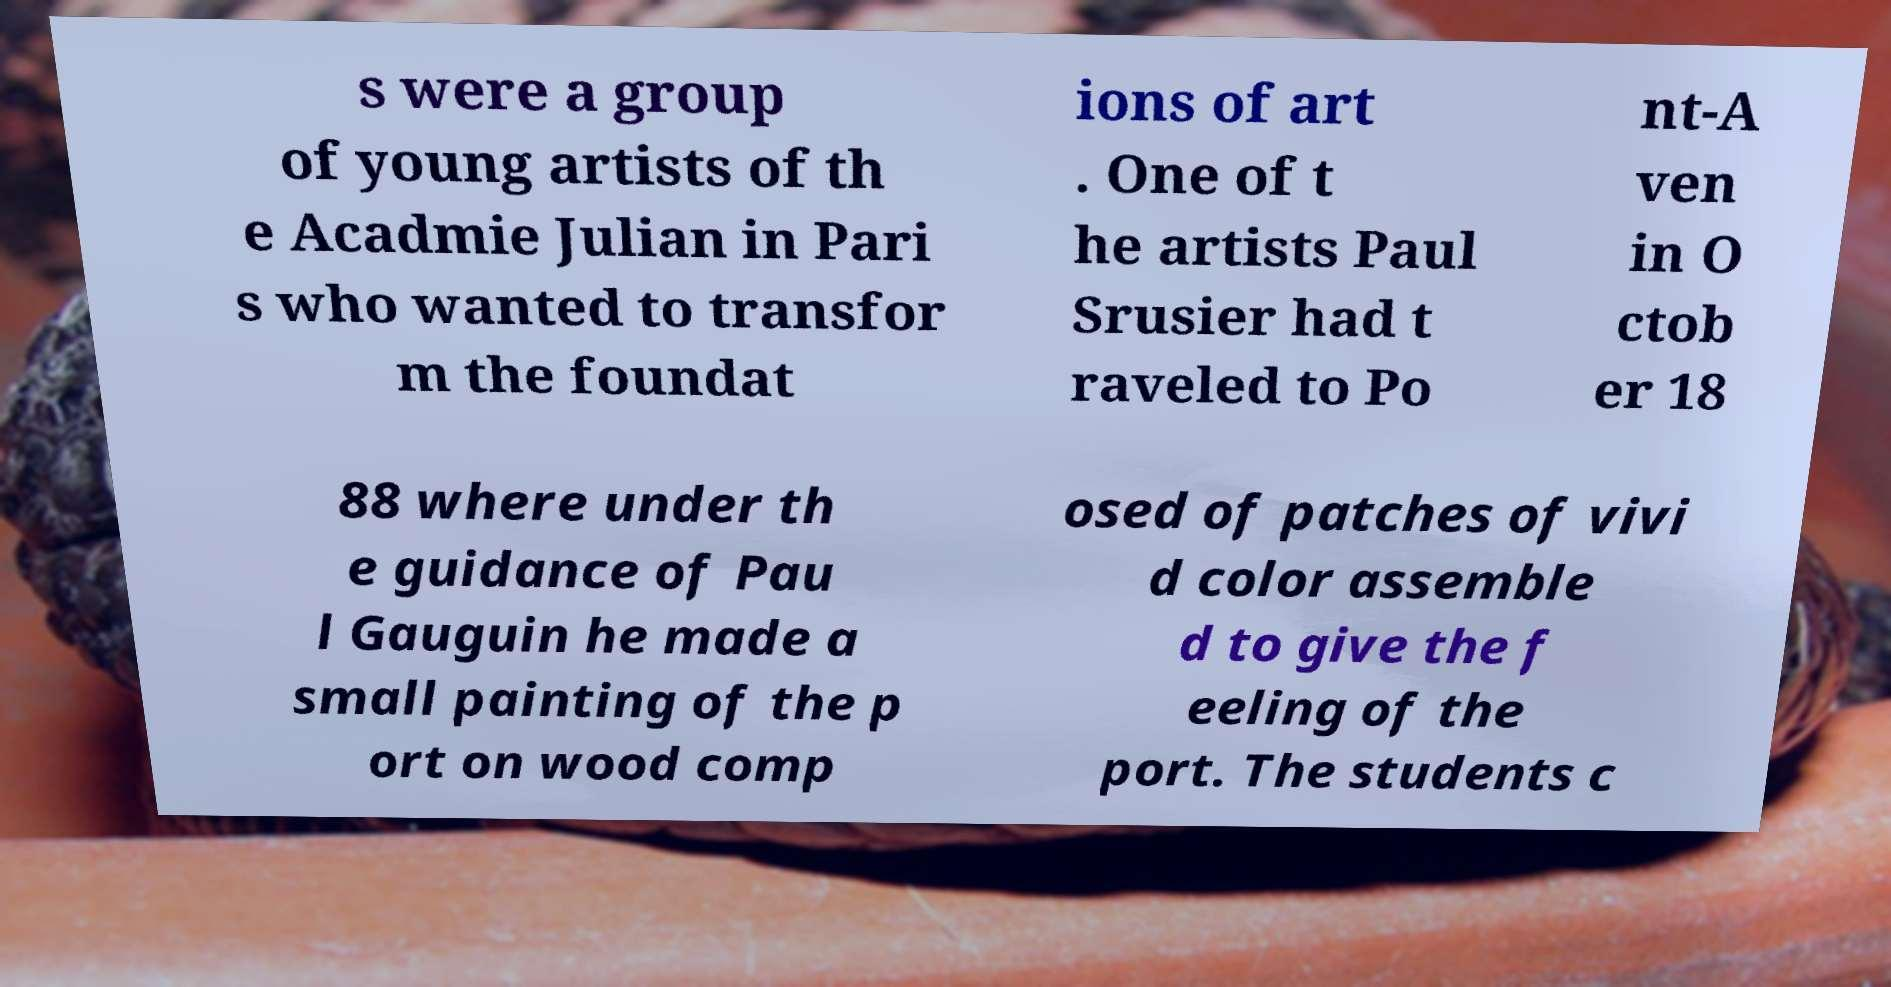There's text embedded in this image that I need extracted. Can you transcribe it verbatim? s were a group of young artists of th e Acadmie Julian in Pari s who wanted to transfor m the foundat ions of art . One of t he artists Paul Srusier had t raveled to Po nt-A ven in O ctob er 18 88 where under th e guidance of Pau l Gauguin he made a small painting of the p ort on wood comp osed of patches of vivi d color assemble d to give the f eeling of the port. The students c 